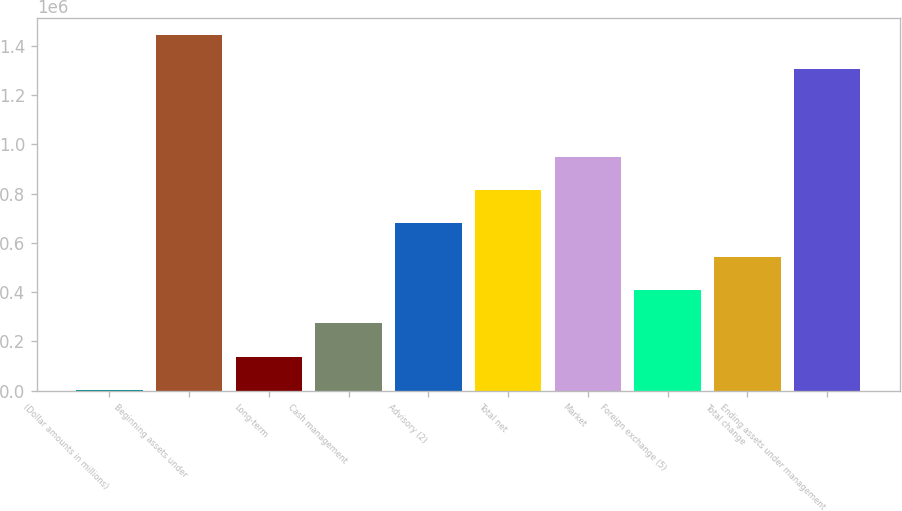Convert chart. <chart><loc_0><loc_0><loc_500><loc_500><bar_chart><fcel>(Dollar amounts in millions)<fcel>Beginning assets under<fcel>Long-term<fcel>Cash management<fcel>Advisory (2)<fcel>Total net<fcel>Market<fcel>Foreign exchange (5)<fcel>Total change<fcel>Ending assets under management<nl><fcel>2008<fcel>1.44261e+06<fcel>137472<fcel>272935<fcel>679326<fcel>814790<fcel>950253<fcel>408399<fcel>543862<fcel>1.30715e+06<nl></chart> 